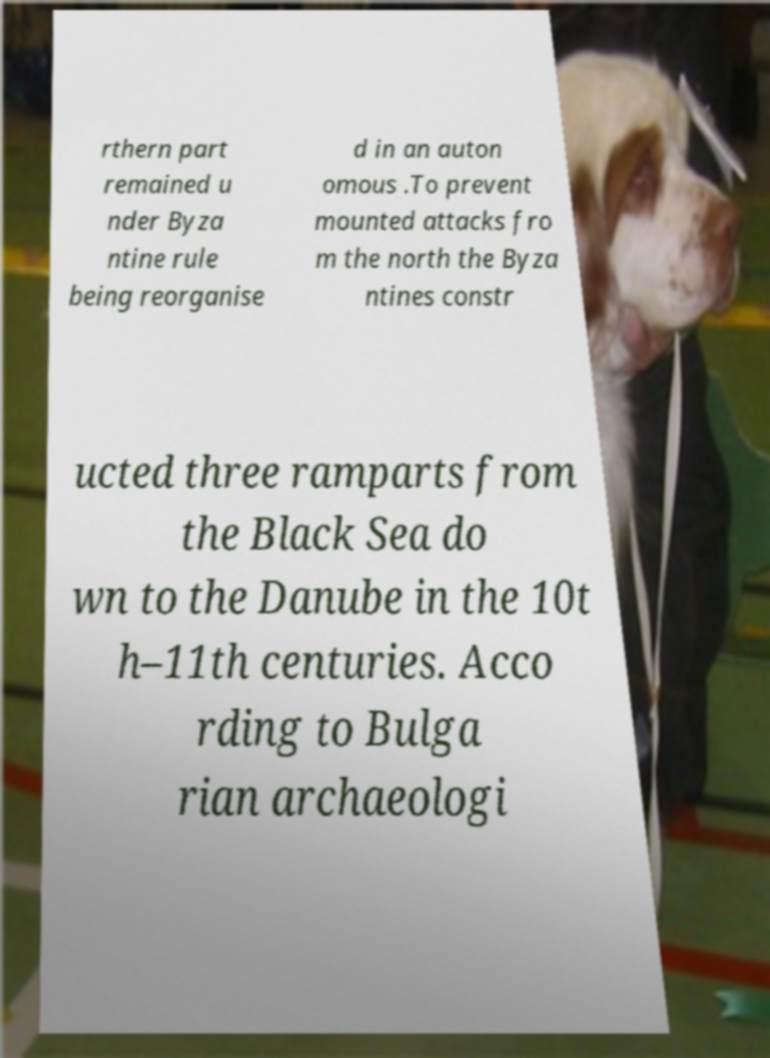Please identify and transcribe the text found in this image. rthern part remained u nder Byza ntine rule being reorganise d in an auton omous .To prevent mounted attacks fro m the north the Byza ntines constr ucted three ramparts from the Black Sea do wn to the Danube in the 10t h–11th centuries. Acco rding to Bulga rian archaeologi 